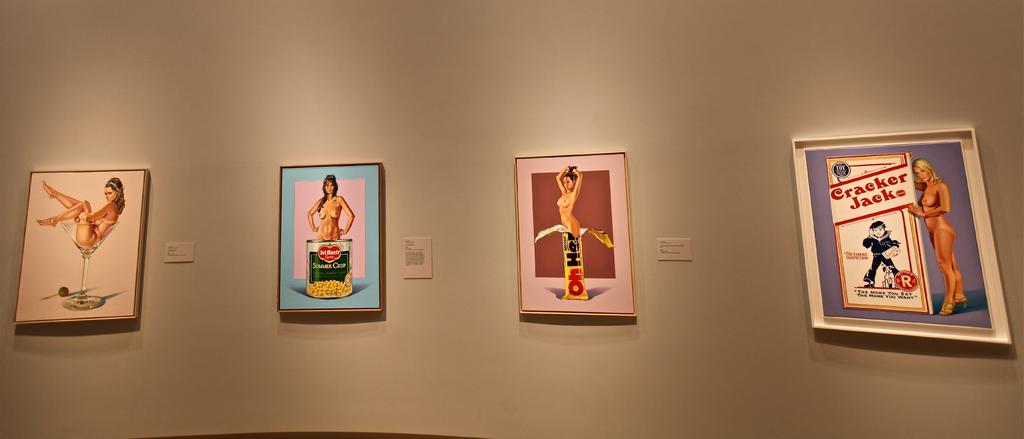What does the box on the right say?
Provide a short and direct response. Cracker jacks. 